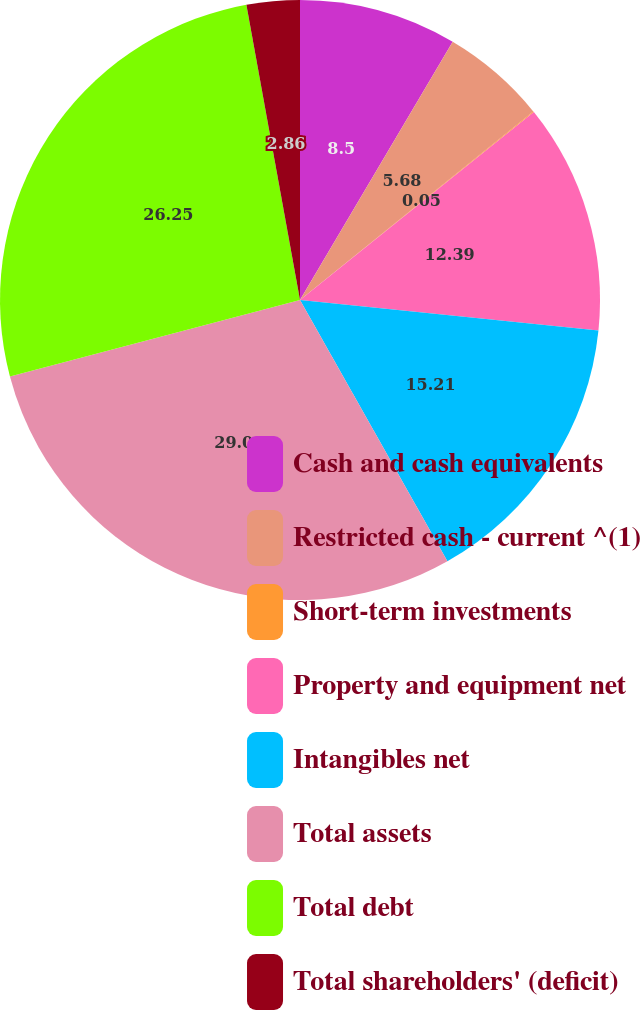Convert chart. <chart><loc_0><loc_0><loc_500><loc_500><pie_chart><fcel>Cash and cash equivalents<fcel>Restricted cash - current ^(1)<fcel>Short-term investments<fcel>Property and equipment net<fcel>Intangibles net<fcel>Total assets<fcel>Total debt<fcel>Total shareholders' (deficit)<nl><fcel>8.5%<fcel>5.68%<fcel>0.05%<fcel>12.39%<fcel>15.21%<fcel>29.07%<fcel>26.25%<fcel>2.86%<nl></chart> 